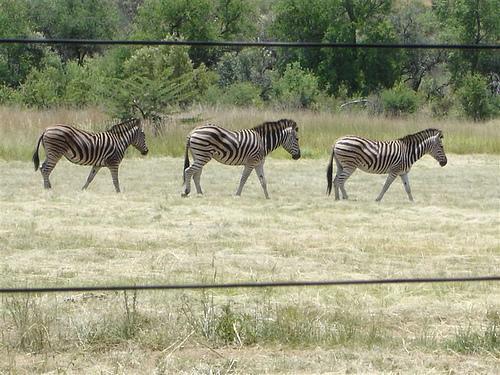How many animals?
Give a very brief answer. 3. How many zebras can be seen?
Give a very brief answer. 3. How many kites in the air?
Give a very brief answer. 0. 